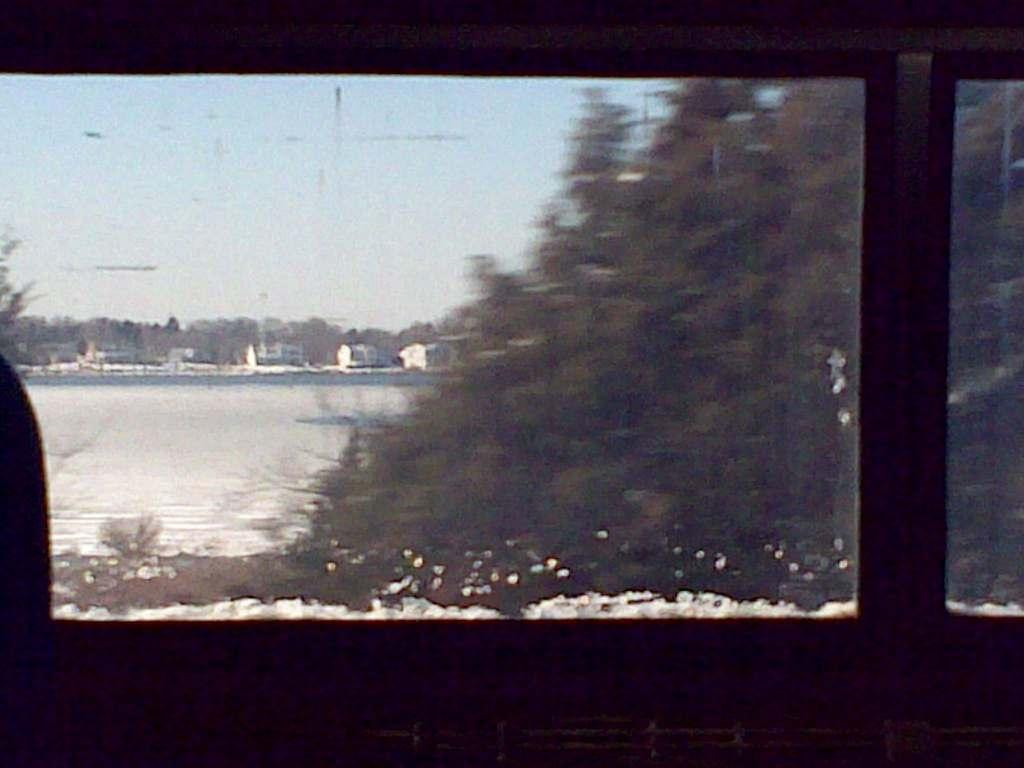What objects in the foreground resemble windows? There are objects in the foreground that resemble windows. What can be seen through the windows? The sky, trees, snow, and other unspecified objects can be seen through the windows. What type of payment is required to enter the home visible through the windows? There is no home visible through the windows in the image, and therefore no payment is required. What type of twig can be seen growing through the windows? There are no twigs visible through the windows in the image. 